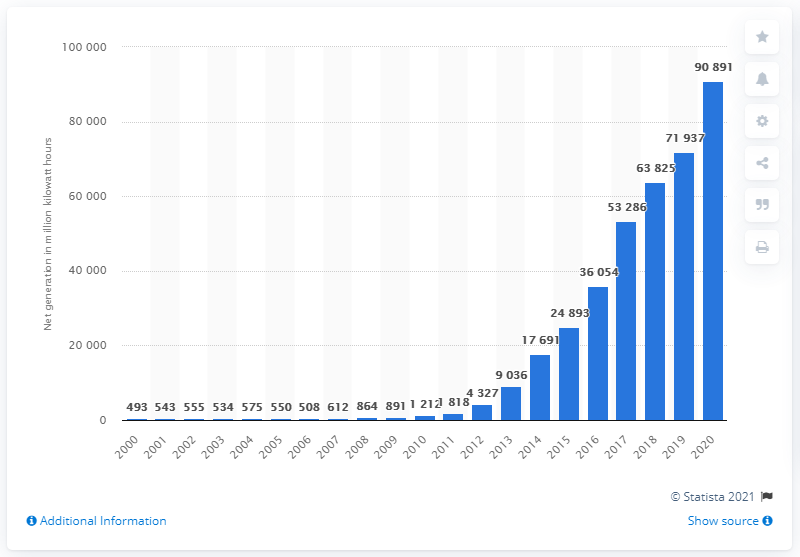Specify some key components in this picture. In 2011, net generation hovered just below two terawatt hours. 